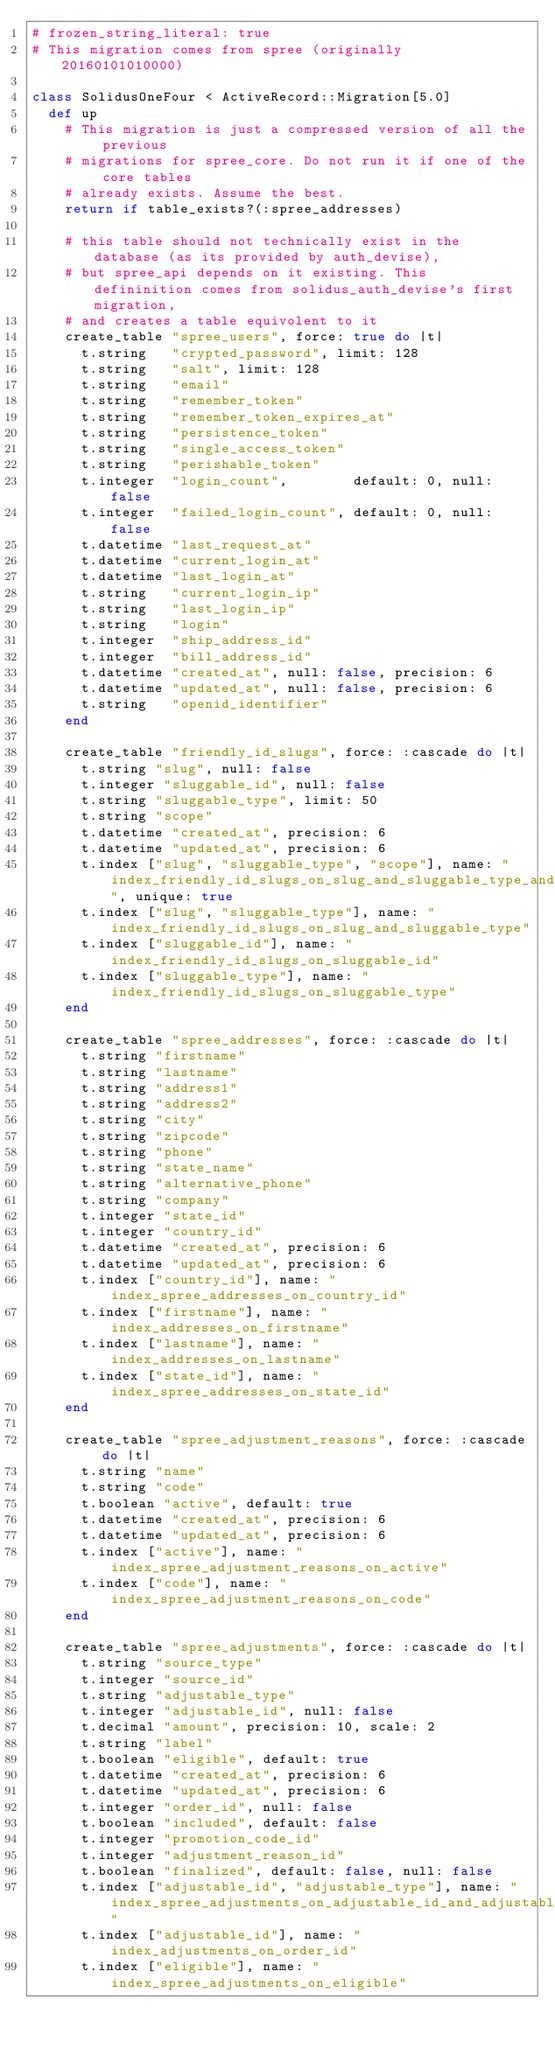Convert code to text. <code><loc_0><loc_0><loc_500><loc_500><_Ruby_># frozen_string_literal: true
# This migration comes from spree (originally 20160101010000)

class SolidusOneFour < ActiveRecord::Migration[5.0]
  def up
    # This migration is just a compressed version of all the previous
    # migrations for spree_core. Do not run it if one of the core tables
    # already exists. Assume the best.
    return if table_exists?(:spree_addresses)

    # this table should not technically exist in the database (as its provided by auth_devise),
    # but spree_api depends on it existing. This defininition comes from solidus_auth_devise's first migration,
    # and creates a table equivolent to it
    create_table "spree_users", force: true do |t|
      t.string   "crypted_password", limit: 128
      t.string   "salt", limit: 128
      t.string   "email"
      t.string   "remember_token"
      t.string   "remember_token_expires_at"
      t.string   "persistence_token"
      t.string   "single_access_token"
      t.string   "perishable_token"
      t.integer  "login_count",        default: 0, null: false
      t.integer  "failed_login_count", default: 0, null: false
      t.datetime "last_request_at"
      t.datetime "current_login_at"
      t.datetime "last_login_at"
      t.string   "current_login_ip"
      t.string   "last_login_ip"
      t.string   "login"
      t.integer  "ship_address_id"
      t.integer  "bill_address_id"
      t.datetime "created_at", null: false, precision: 6
      t.datetime "updated_at", null: false, precision: 6
      t.string   "openid_identifier"
    end

    create_table "friendly_id_slugs", force: :cascade do |t|
      t.string "slug", null: false
      t.integer "sluggable_id", null: false
      t.string "sluggable_type", limit: 50
      t.string "scope"
      t.datetime "created_at", precision: 6
      t.datetime "updated_at", precision: 6
      t.index ["slug", "sluggable_type", "scope"], name: "index_friendly_id_slugs_on_slug_and_sluggable_type_and_scope", unique: true
      t.index ["slug", "sluggable_type"], name: "index_friendly_id_slugs_on_slug_and_sluggable_type"
      t.index ["sluggable_id"], name: "index_friendly_id_slugs_on_sluggable_id"
      t.index ["sluggable_type"], name: "index_friendly_id_slugs_on_sluggable_type"
    end

    create_table "spree_addresses", force: :cascade do |t|
      t.string "firstname"
      t.string "lastname"
      t.string "address1"
      t.string "address2"
      t.string "city"
      t.string "zipcode"
      t.string "phone"
      t.string "state_name"
      t.string "alternative_phone"
      t.string "company"
      t.integer "state_id"
      t.integer "country_id"
      t.datetime "created_at", precision: 6
      t.datetime "updated_at", precision: 6
      t.index ["country_id"], name: "index_spree_addresses_on_country_id"
      t.index ["firstname"], name: "index_addresses_on_firstname"
      t.index ["lastname"], name: "index_addresses_on_lastname"
      t.index ["state_id"], name: "index_spree_addresses_on_state_id"
    end

    create_table "spree_adjustment_reasons", force: :cascade do |t|
      t.string "name"
      t.string "code"
      t.boolean "active", default: true
      t.datetime "created_at", precision: 6
      t.datetime "updated_at", precision: 6
      t.index ["active"], name: "index_spree_adjustment_reasons_on_active"
      t.index ["code"], name: "index_spree_adjustment_reasons_on_code"
    end

    create_table "spree_adjustments", force: :cascade do |t|
      t.string "source_type"
      t.integer "source_id"
      t.string "adjustable_type"
      t.integer "adjustable_id", null: false
      t.decimal "amount", precision: 10, scale: 2
      t.string "label"
      t.boolean "eligible", default: true
      t.datetime "created_at", precision: 6
      t.datetime "updated_at", precision: 6
      t.integer "order_id", null: false
      t.boolean "included", default: false
      t.integer "promotion_code_id"
      t.integer "adjustment_reason_id"
      t.boolean "finalized", default: false, null: false
      t.index ["adjustable_id", "adjustable_type"], name: "index_spree_adjustments_on_adjustable_id_and_adjustable_type"
      t.index ["adjustable_id"], name: "index_adjustments_on_order_id"
      t.index ["eligible"], name: "index_spree_adjustments_on_eligible"</code> 